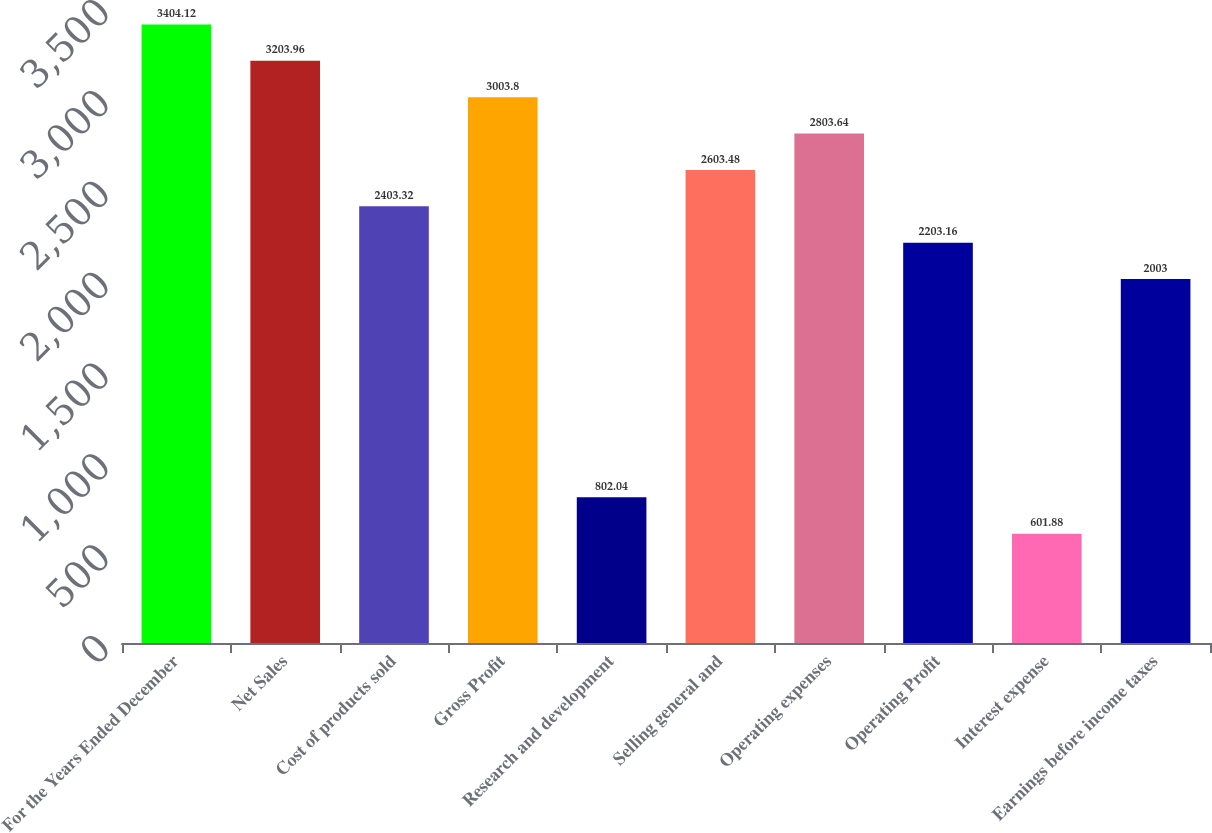<chart> <loc_0><loc_0><loc_500><loc_500><bar_chart><fcel>For the Years Ended December<fcel>Net Sales<fcel>Cost of products sold<fcel>Gross Profit<fcel>Research and development<fcel>Selling general and<fcel>Operating expenses<fcel>Operating Profit<fcel>Interest expense<fcel>Earnings before income taxes<nl><fcel>3404.12<fcel>3203.96<fcel>2403.32<fcel>3003.8<fcel>802.04<fcel>2603.48<fcel>2803.64<fcel>2203.16<fcel>601.88<fcel>2003<nl></chart> 